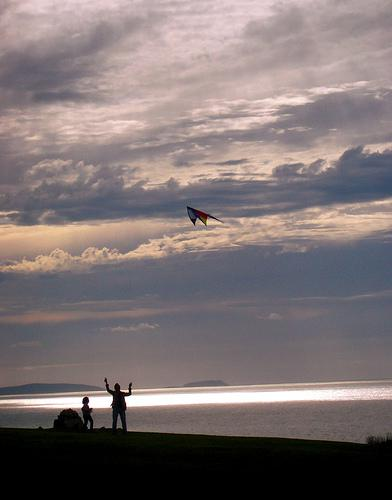Question: what is the man flying?
Choices:
A. A kite.
B. A plane.
C. A helicopter.
D. A drone.
Answer with the letter. Answer: A Question: where are the two people?
Choices:
A. In front of a building.
B. On the couch.
C. At the table.
D. By the water.
Answer with the letter. Answer: D Question: how many people are in the photography?
Choices:
A. Two.
B. Nine.
C. Five.
D. One.
Answer with the letter. Answer: A Question: where are they in the frame?
Choices:
A. To the right side.
B. In the middle.
C. In the background.
D. To the left side.
Answer with the letter. Answer: D Question: how is the adult flying the kite?
Choices:
A. With his hands.
B. With one hand.
C. By himself.
D. With his son.
Answer with the letter. Answer: A 